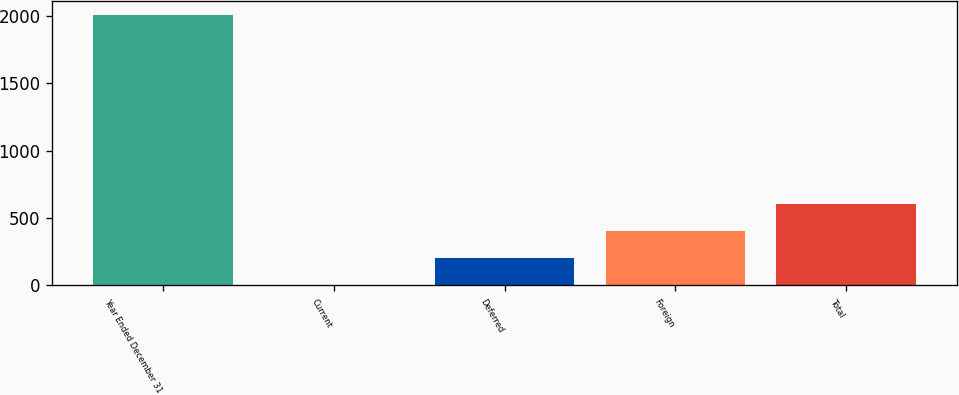Convert chart. <chart><loc_0><loc_0><loc_500><loc_500><bar_chart><fcel>Year Ended December 31<fcel>Current<fcel>Deferred<fcel>Foreign<fcel>Total<nl><fcel>2009<fcel>3<fcel>203.6<fcel>404.2<fcel>604.8<nl></chart> 